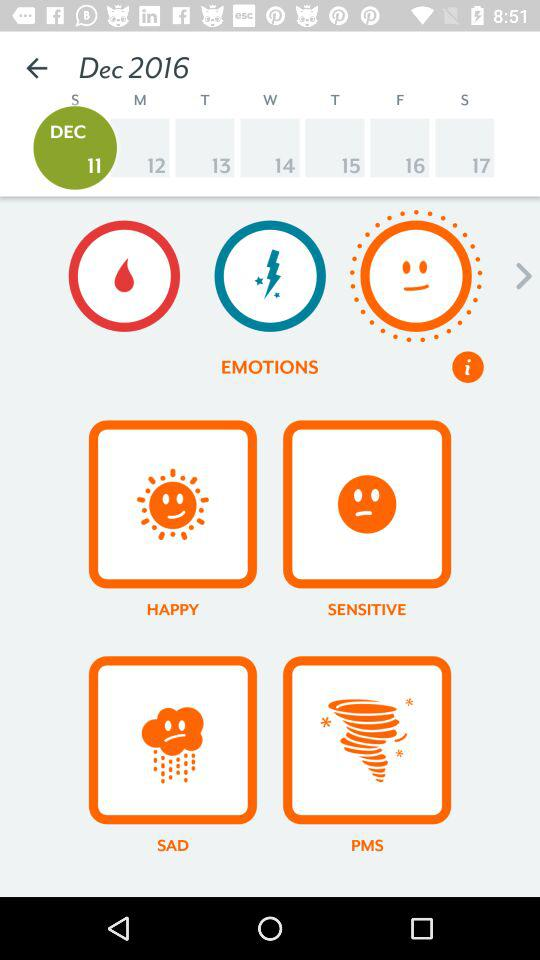What are the types of emotions that I can select? The types of emotions that you can select are "HAPPY", "SENSITIVE", "SAD" and "PMS". 